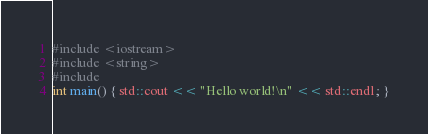Convert code to text. <code><loc_0><loc_0><loc_500><loc_500><_C++_>#include <iostream>
#include <string>
#include
int main() { std::cout << "Hello world!\n" << std::endl; }</code> 